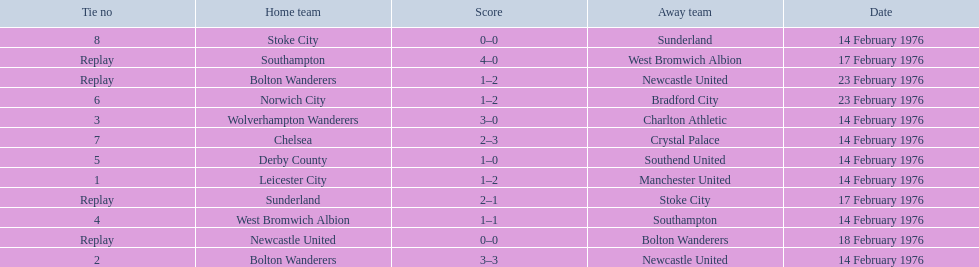Who was the home team in the game on the top of the table? Leicester City. 